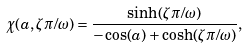Convert formula to latex. <formula><loc_0><loc_0><loc_500><loc_500>\chi ( a , \zeta \pi / \omega ) = \frac { \sinh ( \zeta \pi / \omega ) } { - \cos ( a ) + \cosh ( \zeta \pi / \omega ) } ,</formula> 